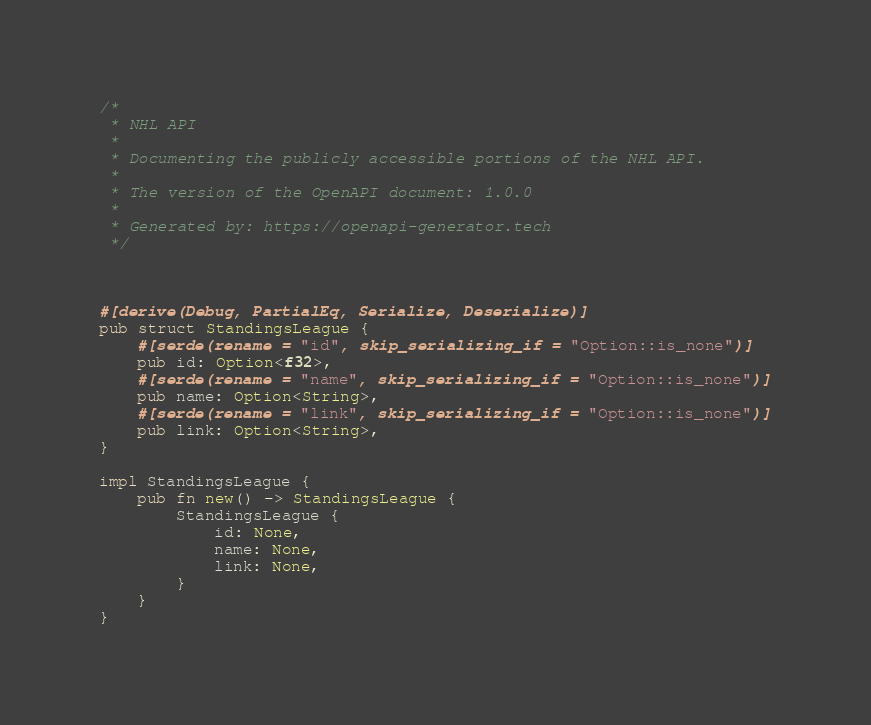Convert code to text. <code><loc_0><loc_0><loc_500><loc_500><_Rust_>/*
 * NHL API
 *
 * Documenting the publicly accessible portions of the NHL API.
 *
 * The version of the OpenAPI document: 1.0.0
 * 
 * Generated by: https://openapi-generator.tech
 */



#[derive(Debug, PartialEq, Serialize, Deserialize)]
pub struct StandingsLeague {
    #[serde(rename = "id", skip_serializing_if = "Option::is_none")]
    pub id: Option<f32>,
    #[serde(rename = "name", skip_serializing_if = "Option::is_none")]
    pub name: Option<String>,
    #[serde(rename = "link", skip_serializing_if = "Option::is_none")]
    pub link: Option<String>,
}

impl StandingsLeague {
    pub fn new() -> StandingsLeague {
        StandingsLeague {
            id: None,
            name: None,
            link: None,
        }
    }
}


</code> 